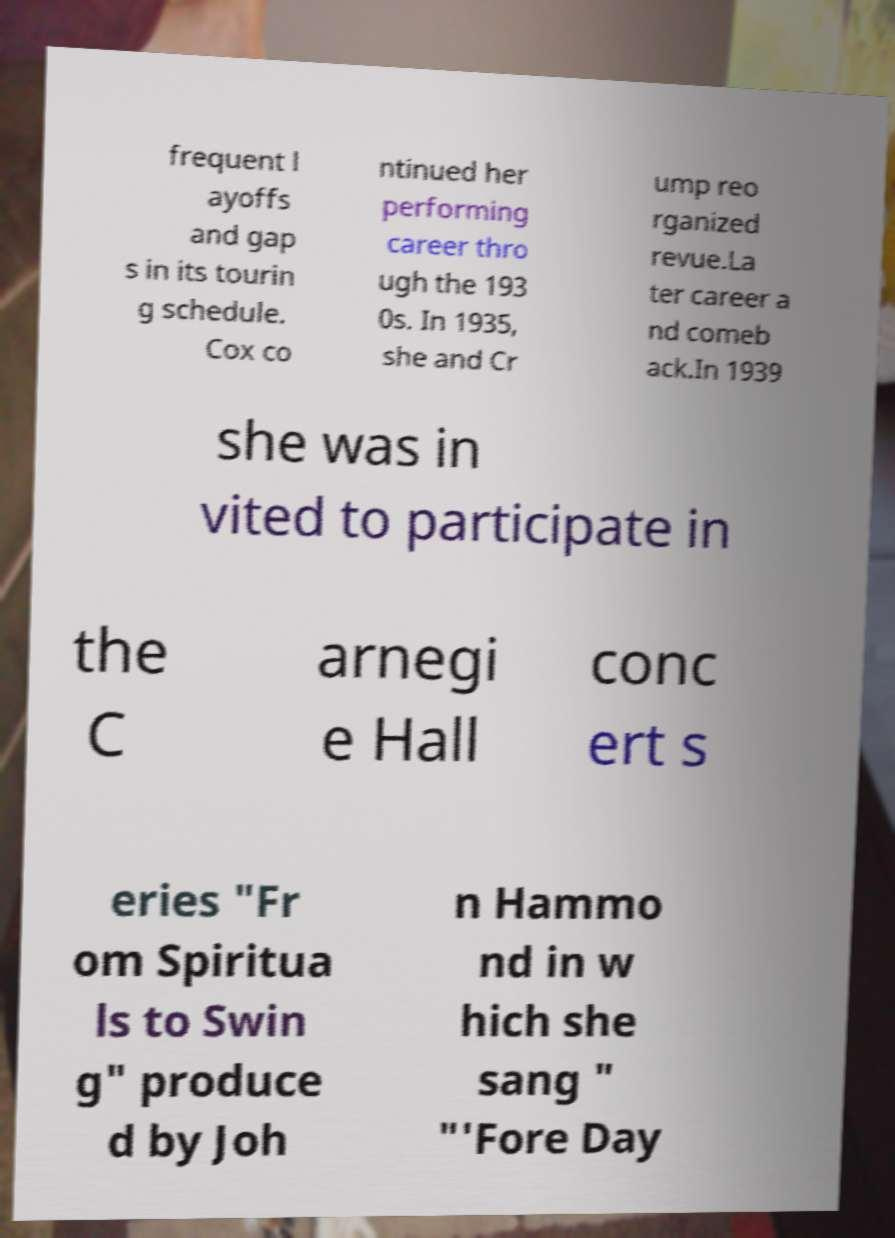Could you extract and type out the text from this image? frequent l ayoffs and gap s in its tourin g schedule. Cox co ntinued her performing career thro ugh the 193 0s. In 1935, she and Cr ump reo rganized revue.La ter career a nd comeb ack.In 1939 she was in vited to participate in the C arnegi e Hall conc ert s eries "Fr om Spiritua ls to Swin g" produce d by Joh n Hammo nd in w hich she sang " "'Fore Day 